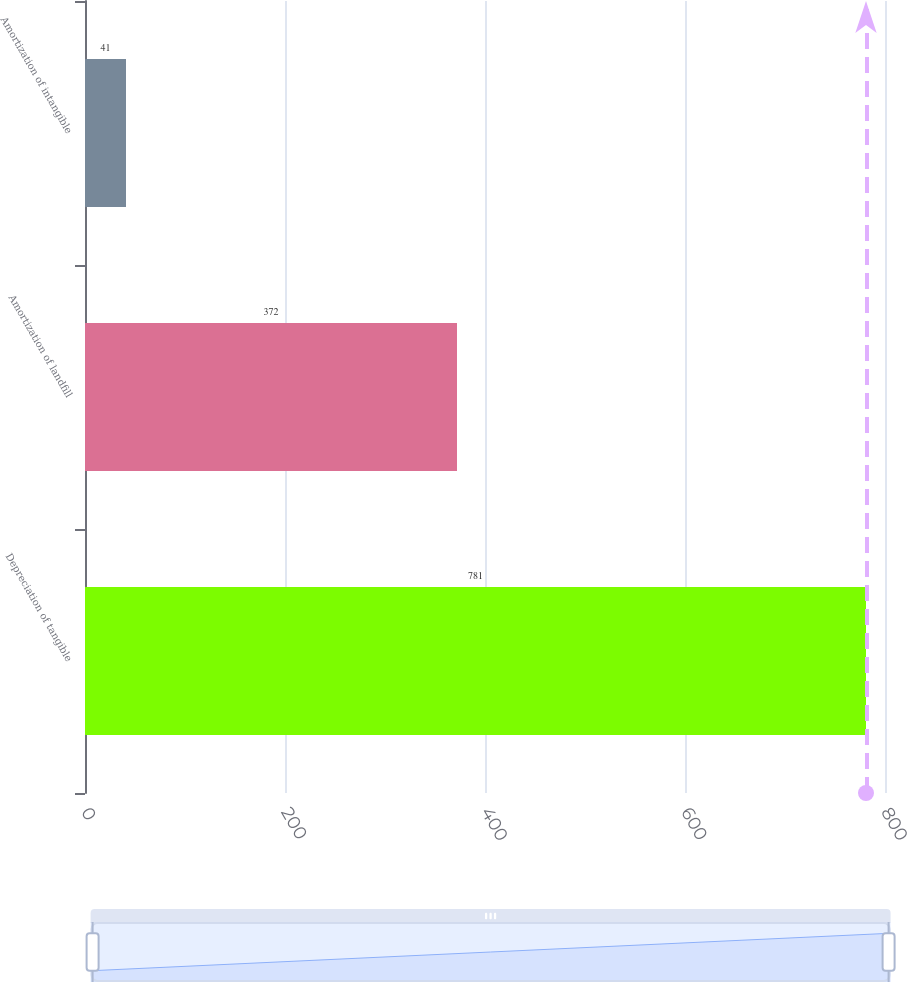<chart> <loc_0><loc_0><loc_500><loc_500><bar_chart><fcel>Depreciation of tangible<fcel>Amortization of landfill<fcel>Amortization of intangible<nl><fcel>781<fcel>372<fcel>41<nl></chart> 